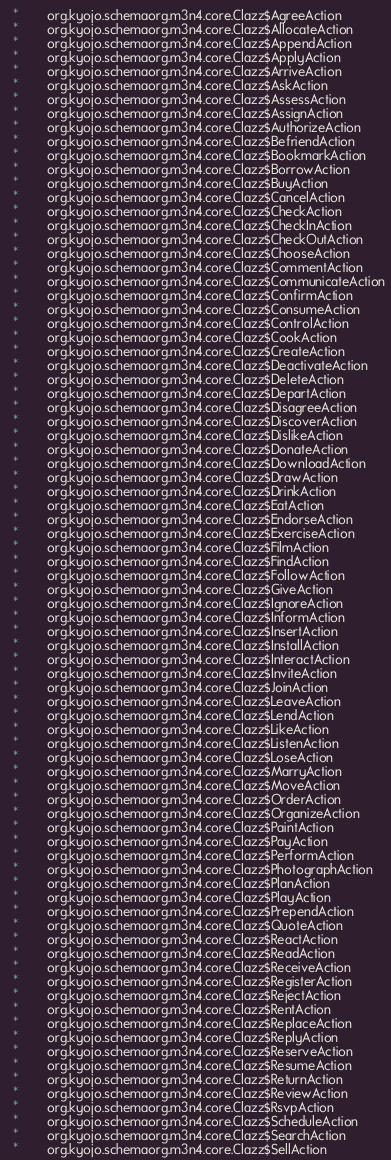Convert code to text. <code><loc_0><loc_0><loc_500><loc_500><_SQL_>  *        org.kyojo.schemaorg.m3n4.core.Clazz$AgreeAction
  *        org.kyojo.schemaorg.m3n4.core.Clazz$AllocateAction
  *        org.kyojo.schemaorg.m3n4.core.Clazz$AppendAction
  *        org.kyojo.schemaorg.m3n4.core.Clazz$ApplyAction
  *        org.kyojo.schemaorg.m3n4.core.Clazz$ArriveAction
  *        org.kyojo.schemaorg.m3n4.core.Clazz$AskAction
  *        org.kyojo.schemaorg.m3n4.core.Clazz$AssessAction
  *        org.kyojo.schemaorg.m3n4.core.Clazz$AssignAction
  *        org.kyojo.schemaorg.m3n4.core.Clazz$AuthorizeAction
  *        org.kyojo.schemaorg.m3n4.core.Clazz$BefriendAction
  *        org.kyojo.schemaorg.m3n4.core.Clazz$BookmarkAction
  *        org.kyojo.schemaorg.m3n4.core.Clazz$BorrowAction
  *        org.kyojo.schemaorg.m3n4.core.Clazz$BuyAction
  *        org.kyojo.schemaorg.m3n4.core.Clazz$CancelAction
  *        org.kyojo.schemaorg.m3n4.core.Clazz$CheckAction
  *        org.kyojo.schemaorg.m3n4.core.Clazz$CheckInAction
  *        org.kyojo.schemaorg.m3n4.core.Clazz$CheckOutAction
  *        org.kyojo.schemaorg.m3n4.core.Clazz$ChooseAction
  *        org.kyojo.schemaorg.m3n4.core.Clazz$CommentAction
  *        org.kyojo.schemaorg.m3n4.core.Clazz$CommunicateAction
  *        org.kyojo.schemaorg.m3n4.core.Clazz$ConfirmAction
  *        org.kyojo.schemaorg.m3n4.core.Clazz$ConsumeAction
  *        org.kyojo.schemaorg.m3n4.core.Clazz$ControlAction
  *        org.kyojo.schemaorg.m3n4.core.Clazz$CookAction
  *        org.kyojo.schemaorg.m3n4.core.Clazz$CreateAction
  *        org.kyojo.schemaorg.m3n4.core.Clazz$DeactivateAction
  *        org.kyojo.schemaorg.m3n4.core.Clazz$DeleteAction
  *        org.kyojo.schemaorg.m3n4.core.Clazz$DepartAction
  *        org.kyojo.schemaorg.m3n4.core.Clazz$DisagreeAction
  *        org.kyojo.schemaorg.m3n4.core.Clazz$DiscoverAction
  *        org.kyojo.schemaorg.m3n4.core.Clazz$DislikeAction
  *        org.kyojo.schemaorg.m3n4.core.Clazz$DonateAction
  *        org.kyojo.schemaorg.m3n4.core.Clazz$DownloadAction
  *        org.kyojo.schemaorg.m3n4.core.Clazz$DrawAction
  *        org.kyojo.schemaorg.m3n4.core.Clazz$DrinkAction
  *        org.kyojo.schemaorg.m3n4.core.Clazz$EatAction
  *        org.kyojo.schemaorg.m3n4.core.Clazz$EndorseAction
  *        org.kyojo.schemaorg.m3n4.core.Clazz$ExerciseAction
  *        org.kyojo.schemaorg.m3n4.core.Clazz$FilmAction
  *        org.kyojo.schemaorg.m3n4.core.Clazz$FindAction
  *        org.kyojo.schemaorg.m3n4.core.Clazz$FollowAction
  *        org.kyojo.schemaorg.m3n4.core.Clazz$GiveAction
  *        org.kyojo.schemaorg.m3n4.core.Clazz$IgnoreAction
  *        org.kyojo.schemaorg.m3n4.core.Clazz$InformAction
  *        org.kyojo.schemaorg.m3n4.core.Clazz$InsertAction
  *        org.kyojo.schemaorg.m3n4.core.Clazz$InstallAction
  *        org.kyojo.schemaorg.m3n4.core.Clazz$InteractAction
  *        org.kyojo.schemaorg.m3n4.core.Clazz$InviteAction
  *        org.kyojo.schemaorg.m3n4.core.Clazz$JoinAction
  *        org.kyojo.schemaorg.m3n4.core.Clazz$LeaveAction
  *        org.kyojo.schemaorg.m3n4.core.Clazz$LendAction
  *        org.kyojo.schemaorg.m3n4.core.Clazz$LikeAction
  *        org.kyojo.schemaorg.m3n4.core.Clazz$ListenAction
  *        org.kyojo.schemaorg.m3n4.core.Clazz$LoseAction
  *        org.kyojo.schemaorg.m3n4.core.Clazz$MarryAction
  *        org.kyojo.schemaorg.m3n4.core.Clazz$MoveAction
  *        org.kyojo.schemaorg.m3n4.core.Clazz$OrderAction
  *        org.kyojo.schemaorg.m3n4.core.Clazz$OrganizeAction
  *        org.kyojo.schemaorg.m3n4.core.Clazz$PaintAction
  *        org.kyojo.schemaorg.m3n4.core.Clazz$PayAction
  *        org.kyojo.schemaorg.m3n4.core.Clazz$PerformAction
  *        org.kyojo.schemaorg.m3n4.core.Clazz$PhotographAction
  *        org.kyojo.schemaorg.m3n4.core.Clazz$PlanAction
  *        org.kyojo.schemaorg.m3n4.core.Clazz$PlayAction
  *        org.kyojo.schemaorg.m3n4.core.Clazz$PrependAction
  *        org.kyojo.schemaorg.m3n4.core.Clazz$QuoteAction
  *        org.kyojo.schemaorg.m3n4.core.Clazz$ReactAction
  *        org.kyojo.schemaorg.m3n4.core.Clazz$ReadAction
  *        org.kyojo.schemaorg.m3n4.core.Clazz$ReceiveAction
  *        org.kyojo.schemaorg.m3n4.core.Clazz$RegisterAction
  *        org.kyojo.schemaorg.m3n4.core.Clazz$RejectAction
  *        org.kyojo.schemaorg.m3n4.core.Clazz$RentAction
  *        org.kyojo.schemaorg.m3n4.core.Clazz$ReplaceAction
  *        org.kyojo.schemaorg.m3n4.core.Clazz$ReplyAction
  *        org.kyojo.schemaorg.m3n4.core.Clazz$ReserveAction
  *        org.kyojo.schemaorg.m3n4.core.Clazz$ResumeAction
  *        org.kyojo.schemaorg.m3n4.core.Clazz$ReturnAction
  *        org.kyojo.schemaorg.m3n4.core.Clazz$ReviewAction
  *        org.kyojo.schemaorg.m3n4.core.Clazz$RsvpAction
  *        org.kyojo.schemaorg.m3n4.core.Clazz$ScheduleAction
  *        org.kyojo.schemaorg.m3n4.core.Clazz$SearchAction
  *        org.kyojo.schemaorg.m3n4.core.Clazz$SellAction</code> 